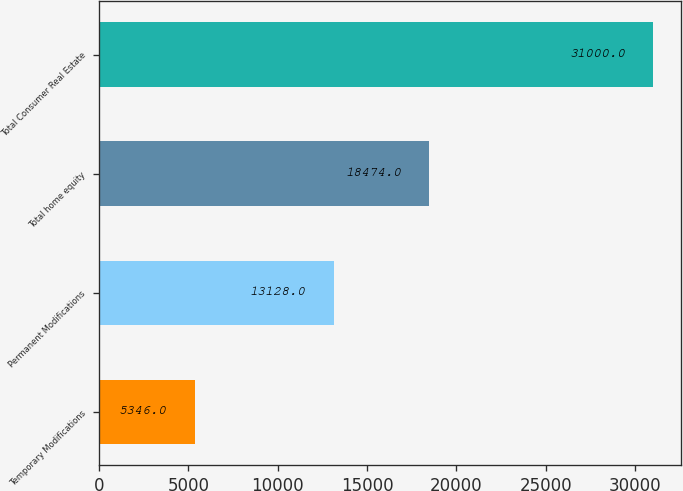Convert chart. <chart><loc_0><loc_0><loc_500><loc_500><bar_chart><fcel>Temporary Modifications<fcel>Permanent Modifications<fcel>Total home equity<fcel>Total Consumer Real Estate<nl><fcel>5346<fcel>13128<fcel>18474<fcel>31000<nl></chart> 